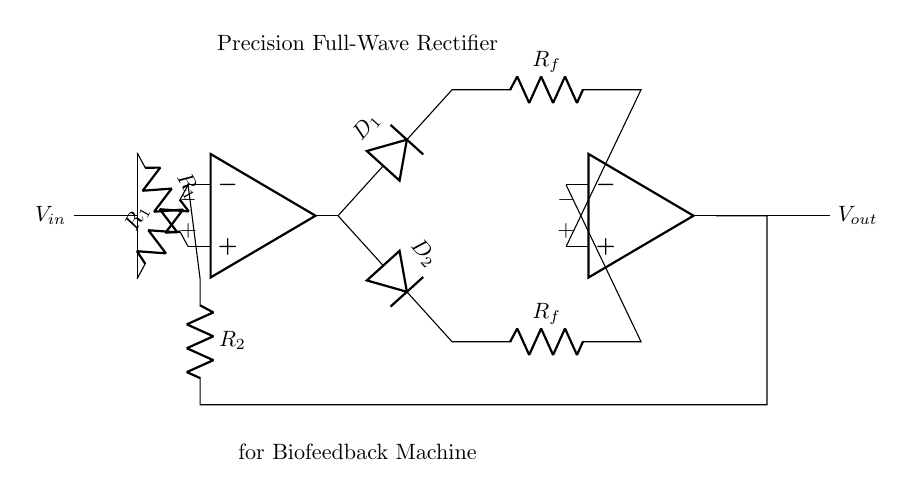What is the function of this circuit? The circuit functions as a precision full-wave rectifier, which converts an alternating current input signal into a direct current output signal.
Answer: Precision full-wave rectifier How many op-amps are used in this circuit? The circuit uses two operational amplifiers, which are crucial for processing the input signals.
Answer: Two What are the labels of the diodes in the circuit? The diodes are labeled as D1 and D2, indicating their positions in the full-wave rectification process.
Answer: D1 and D2 What is the resistance value of R_f? The resistance is denoted as R_f, but the specific numerical value isn't given in the circuit diagram. It signifies a feedback resistor that can affect the amplification factors.
Answer: R_f How many resistors are in the circuit? There are three distinct resistors in the circuit: two labeled R1 and one labeled R2, which are critical for setting gains and feedback.
Answer: Three What type of load can be connected at the output? The circuit output, labeled V_out, can connect to various types of loads, typically a measurement device or feedback loop, suitable for monitoring subconscious responses in a biofeedback machine.
Answer: Measurement device Which pins of the op-amps are connected to the diodes? The output pin of the first op-amp (opamp1.out) is connected to both D1 and D2, leading to the inverting terminal connections of the second op-amp (opamp2).
Answer: Output pins to D1 and D2 